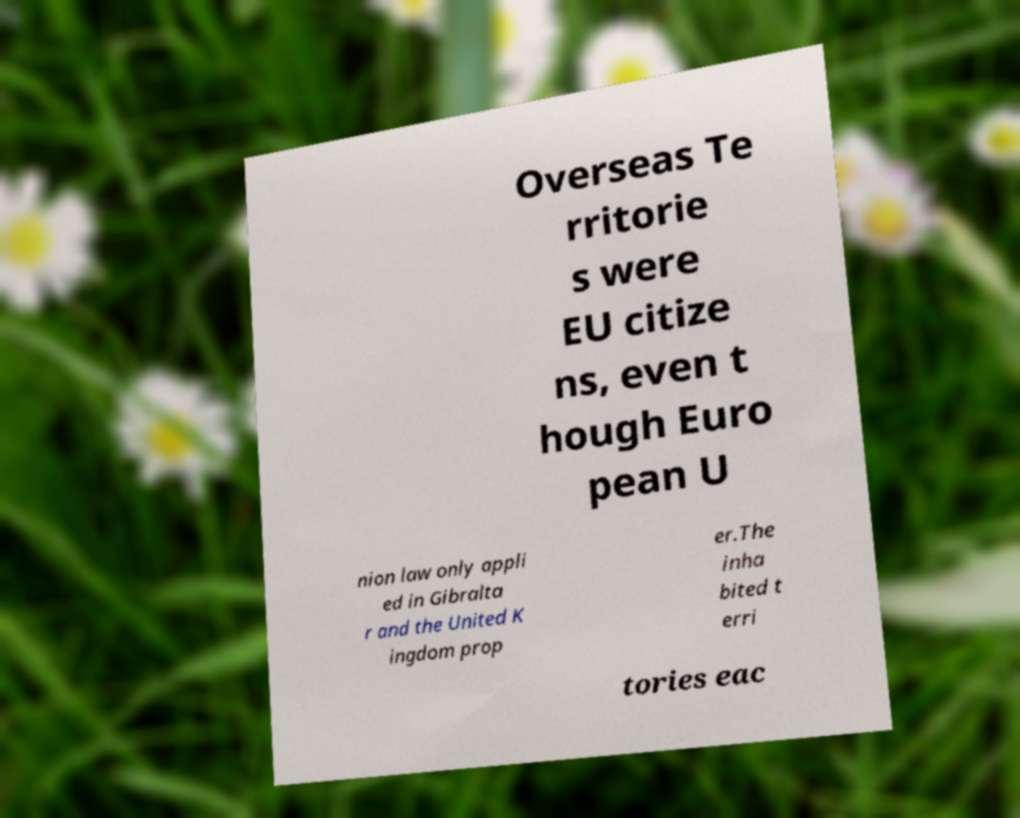Can you accurately transcribe the text from the provided image for me? Overseas Te rritorie s were EU citize ns, even t hough Euro pean U nion law only appli ed in Gibralta r and the United K ingdom prop er.The inha bited t erri tories eac 